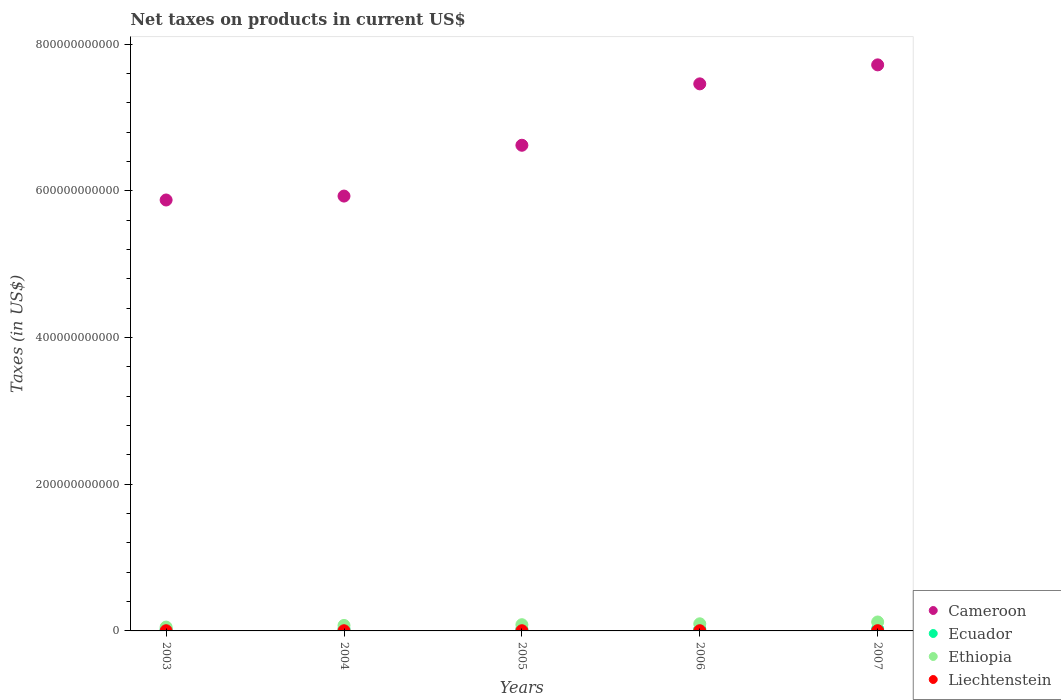What is the net taxes on products in Cameroon in 2003?
Give a very brief answer. 5.87e+11. Across all years, what is the maximum net taxes on products in Liechtenstein?
Provide a succinct answer. 3.35e+08. Across all years, what is the minimum net taxes on products in Cameroon?
Keep it short and to the point. 5.87e+11. In which year was the net taxes on products in Ecuador maximum?
Your answer should be very brief. 2007. In which year was the net taxes on products in Cameroon minimum?
Your answer should be compact. 2003. What is the total net taxes on products in Liechtenstein in the graph?
Offer a terse response. 1.40e+09. What is the difference between the net taxes on products in Ecuador in 2005 and that in 2007?
Provide a short and direct response. -1.95e+08. What is the difference between the net taxes on products in Liechtenstein in 2006 and the net taxes on products in Cameroon in 2005?
Offer a terse response. -6.62e+11. What is the average net taxes on products in Ecuador per year?
Provide a short and direct response. 2.35e+09. In the year 2004, what is the difference between the net taxes on products in Ethiopia and net taxes on products in Cameroon?
Make the answer very short. -5.85e+11. What is the ratio of the net taxes on products in Ecuador in 2004 to that in 2007?
Offer a very short reply. 0.96. Is the difference between the net taxes on products in Ethiopia in 2004 and 2007 greater than the difference between the net taxes on products in Cameroon in 2004 and 2007?
Make the answer very short. Yes. What is the difference between the highest and the second highest net taxes on products in Cameroon?
Provide a succinct answer. 2.59e+1. What is the difference between the highest and the lowest net taxes on products in Ethiopia?
Your response must be concise. 6.96e+09. In how many years, is the net taxes on products in Ecuador greater than the average net taxes on products in Ecuador taken over all years?
Keep it short and to the point. 2. Is the sum of the net taxes on products in Cameroon in 2004 and 2007 greater than the maximum net taxes on products in Liechtenstein across all years?
Offer a terse response. Yes. Is it the case that in every year, the sum of the net taxes on products in Ethiopia and net taxes on products in Ecuador  is greater than the net taxes on products in Liechtenstein?
Offer a very short reply. Yes. Does the net taxes on products in Ecuador monotonically increase over the years?
Your response must be concise. No. Is the net taxes on products in Cameroon strictly greater than the net taxes on products in Liechtenstein over the years?
Offer a terse response. Yes. How many dotlines are there?
Give a very brief answer. 4. How many years are there in the graph?
Provide a succinct answer. 5. What is the difference between two consecutive major ticks on the Y-axis?
Your answer should be compact. 2.00e+11. Does the graph contain grids?
Offer a very short reply. No. Where does the legend appear in the graph?
Your answer should be compact. Bottom right. How many legend labels are there?
Give a very brief answer. 4. How are the legend labels stacked?
Offer a terse response. Vertical. What is the title of the graph?
Provide a short and direct response. Net taxes on products in current US$. Does "Virgin Islands" appear as one of the legend labels in the graph?
Offer a terse response. No. What is the label or title of the X-axis?
Your answer should be very brief. Years. What is the label or title of the Y-axis?
Your answer should be compact. Taxes (in US$). What is the Taxes (in US$) in Cameroon in 2003?
Your response must be concise. 5.87e+11. What is the Taxes (in US$) in Ecuador in 2003?
Provide a short and direct response. 2.26e+09. What is the Taxes (in US$) of Ethiopia in 2003?
Give a very brief answer. 5.23e+09. What is the Taxes (in US$) in Liechtenstein in 2003?
Make the answer very short. 2.70e+08. What is the Taxes (in US$) of Cameroon in 2004?
Provide a short and direct response. 5.93e+11. What is the Taxes (in US$) of Ecuador in 2004?
Provide a succinct answer. 2.39e+09. What is the Taxes (in US$) of Ethiopia in 2004?
Ensure brevity in your answer.  7.48e+09. What is the Taxes (in US$) in Liechtenstein in 2004?
Give a very brief answer. 2.39e+08. What is the Taxes (in US$) in Cameroon in 2005?
Make the answer very short. 6.62e+11. What is the Taxes (in US$) of Ecuador in 2005?
Give a very brief answer. 2.30e+09. What is the Taxes (in US$) in Ethiopia in 2005?
Your answer should be very brief. 8.47e+09. What is the Taxes (in US$) in Liechtenstein in 2005?
Give a very brief answer. 2.62e+08. What is the Taxes (in US$) of Cameroon in 2006?
Provide a short and direct response. 7.46e+11. What is the Taxes (in US$) in Ecuador in 2006?
Give a very brief answer. 2.30e+09. What is the Taxes (in US$) of Ethiopia in 2006?
Your response must be concise. 9.70e+09. What is the Taxes (in US$) of Liechtenstein in 2006?
Provide a succinct answer. 2.92e+08. What is the Taxes (in US$) in Cameroon in 2007?
Offer a terse response. 7.72e+11. What is the Taxes (in US$) in Ecuador in 2007?
Your answer should be very brief. 2.50e+09. What is the Taxes (in US$) of Ethiopia in 2007?
Your answer should be compact. 1.22e+1. What is the Taxes (in US$) in Liechtenstein in 2007?
Your response must be concise. 3.35e+08. Across all years, what is the maximum Taxes (in US$) in Cameroon?
Keep it short and to the point. 7.72e+11. Across all years, what is the maximum Taxes (in US$) of Ecuador?
Your answer should be compact. 2.50e+09. Across all years, what is the maximum Taxes (in US$) in Ethiopia?
Offer a terse response. 1.22e+1. Across all years, what is the maximum Taxes (in US$) in Liechtenstein?
Offer a very short reply. 3.35e+08. Across all years, what is the minimum Taxes (in US$) of Cameroon?
Provide a succinct answer. 5.87e+11. Across all years, what is the minimum Taxes (in US$) in Ecuador?
Your response must be concise. 2.26e+09. Across all years, what is the minimum Taxes (in US$) of Ethiopia?
Your answer should be very brief. 5.23e+09. Across all years, what is the minimum Taxes (in US$) of Liechtenstein?
Your answer should be very brief. 2.39e+08. What is the total Taxes (in US$) in Cameroon in the graph?
Offer a very short reply. 3.36e+12. What is the total Taxes (in US$) of Ecuador in the graph?
Your answer should be very brief. 1.18e+1. What is the total Taxes (in US$) of Ethiopia in the graph?
Your response must be concise. 4.31e+1. What is the total Taxes (in US$) of Liechtenstein in the graph?
Make the answer very short. 1.40e+09. What is the difference between the Taxes (in US$) in Cameroon in 2003 and that in 2004?
Keep it short and to the point. -5.34e+09. What is the difference between the Taxes (in US$) in Ecuador in 2003 and that in 2004?
Ensure brevity in your answer.  -1.32e+08. What is the difference between the Taxes (in US$) in Ethiopia in 2003 and that in 2004?
Offer a terse response. -2.25e+09. What is the difference between the Taxes (in US$) in Liechtenstein in 2003 and that in 2004?
Ensure brevity in your answer.  3.08e+07. What is the difference between the Taxes (in US$) of Cameroon in 2003 and that in 2005?
Ensure brevity in your answer.  -7.46e+1. What is the difference between the Taxes (in US$) of Ecuador in 2003 and that in 2005?
Offer a terse response. -4.03e+07. What is the difference between the Taxes (in US$) in Ethiopia in 2003 and that in 2005?
Make the answer very short. -3.24e+09. What is the difference between the Taxes (in US$) in Liechtenstein in 2003 and that in 2005?
Keep it short and to the point. 8.20e+06. What is the difference between the Taxes (in US$) of Cameroon in 2003 and that in 2006?
Keep it short and to the point. -1.58e+11. What is the difference between the Taxes (in US$) in Ecuador in 2003 and that in 2006?
Keep it short and to the point. -4.33e+07. What is the difference between the Taxes (in US$) in Ethiopia in 2003 and that in 2006?
Provide a short and direct response. -4.47e+09. What is the difference between the Taxes (in US$) of Liechtenstein in 2003 and that in 2006?
Your answer should be very brief. -2.19e+07. What is the difference between the Taxes (in US$) of Cameroon in 2003 and that in 2007?
Give a very brief answer. -1.84e+11. What is the difference between the Taxes (in US$) of Ecuador in 2003 and that in 2007?
Make the answer very short. -2.35e+08. What is the difference between the Taxes (in US$) in Ethiopia in 2003 and that in 2007?
Offer a very short reply. -6.96e+09. What is the difference between the Taxes (in US$) in Liechtenstein in 2003 and that in 2007?
Give a very brief answer. -6.54e+07. What is the difference between the Taxes (in US$) in Cameroon in 2004 and that in 2005?
Provide a succinct answer. -6.93e+1. What is the difference between the Taxes (in US$) in Ecuador in 2004 and that in 2005?
Keep it short and to the point. 9.16e+07. What is the difference between the Taxes (in US$) of Ethiopia in 2004 and that in 2005?
Provide a short and direct response. -9.91e+08. What is the difference between the Taxes (in US$) of Liechtenstein in 2004 and that in 2005?
Provide a short and direct response. -2.26e+07. What is the difference between the Taxes (in US$) of Cameroon in 2004 and that in 2006?
Your answer should be very brief. -1.53e+11. What is the difference between the Taxes (in US$) in Ecuador in 2004 and that in 2006?
Provide a succinct answer. 8.86e+07. What is the difference between the Taxes (in US$) of Ethiopia in 2004 and that in 2006?
Your answer should be very brief. -2.22e+09. What is the difference between the Taxes (in US$) in Liechtenstein in 2004 and that in 2006?
Your response must be concise. -5.27e+07. What is the difference between the Taxes (in US$) in Cameroon in 2004 and that in 2007?
Your answer should be very brief. -1.79e+11. What is the difference between the Taxes (in US$) in Ecuador in 2004 and that in 2007?
Offer a very short reply. -1.03e+08. What is the difference between the Taxes (in US$) in Ethiopia in 2004 and that in 2007?
Make the answer very short. -4.71e+09. What is the difference between the Taxes (in US$) of Liechtenstein in 2004 and that in 2007?
Offer a terse response. -9.62e+07. What is the difference between the Taxes (in US$) in Cameroon in 2005 and that in 2006?
Offer a very short reply. -8.37e+1. What is the difference between the Taxes (in US$) of Ecuador in 2005 and that in 2006?
Your answer should be very brief. -2.96e+06. What is the difference between the Taxes (in US$) in Ethiopia in 2005 and that in 2006?
Your answer should be compact. -1.23e+09. What is the difference between the Taxes (in US$) in Liechtenstein in 2005 and that in 2006?
Give a very brief answer. -3.01e+07. What is the difference between the Taxes (in US$) of Cameroon in 2005 and that in 2007?
Give a very brief answer. -1.10e+11. What is the difference between the Taxes (in US$) of Ecuador in 2005 and that in 2007?
Provide a short and direct response. -1.95e+08. What is the difference between the Taxes (in US$) of Ethiopia in 2005 and that in 2007?
Your response must be concise. -3.72e+09. What is the difference between the Taxes (in US$) of Liechtenstein in 2005 and that in 2007?
Offer a terse response. -7.36e+07. What is the difference between the Taxes (in US$) in Cameroon in 2006 and that in 2007?
Your answer should be compact. -2.59e+1. What is the difference between the Taxes (in US$) of Ecuador in 2006 and that in 2007?
Keep it short and to the point. -1.92e+08. What is the difference between the Taxes (in US$) in Ethiopia in 2006 and that in 2007?
Provide a short and direct response. -2.49e+09. What is the difference between the Taxes (in US$) of Liechtenstein in 2006 and that in 2007?
Provide a succinct answer. -4.35e+07. What is the difference between the Taxes (in US$) of Cameroon in 2003 and the Taxes (in US$) of Ecuador in 2004?
Ensure brevity in your answer.  5.85e+11. What is the difference between the Taxes (in US$) of Cameroon in 2003 and the Taxes (in US$) of Ethiopia in 2004?
Keep it short and to the point. 5.80e+11. What is the difference between the Taxes (in US$) in Cameroon in 2003 and the Taxes (in US$) in Liechtenstein in 2004?
Your answer should be very brief. 5.87e+11. What is the difference between the Taxes (in US$) of Ecuador in 2003 and the Taxes (in US$) of Ethiopia in 2004?
Your response must be concise. -5.21e+09. What is the difference between the Taxes (in US$) of Ecuador in 2003 and the Taxes (in US$) of Liechtenstein in 2004?
Make the answer very short. 2.02e+09. What is the difference between the Taxes (in US$) of Ethiopia in 2003 and the Taxes (in US$) of Liechtenstein in 2004?
Make the answer very short. 4.99e+09. What is the difference between the Taxes (in US$) in Cameroon in 2003 and the Taxes (in US$) in Ecuador in 2005?
Keep it short and to the point. 5.85e+11. What is the difference between the Taxes (in US$) in Cameroon in 2003 and the Taxes (in US$) in Ethiopia in 2005?
Your response must be concise. 5.79e+11. What is the difference between the Taxes (in US$) in Cameroon in 2003 and the Taxes (in US$) in Liechtenstein in 2005?
Offer a terse response. 5.87e+11. What is the difference between the Taxes (in US$) of Ecuador in 2003 and the Taxes (in US$) of Ethiopia in 2005?
Provide a succinct answer. -6.21e+09. What is the difference between the Taxes (in US$) in Ecuador in 2003 and the Taxes (in US$) in Liechtenstein in 2005?
Give a very brief answer. 2.00e+09. What is the difference between the Taxes (in US$) in Ethiopia in 2003 and the Taxes (in US$) in Liechtenstein in 2005?
Your answer should be very brief. 4.97e+09. What is the difference between the Taxes (in US$) of Cameroon in 2003 and the Taxes (in US$) of Ecuador in 2006?
Give a very brief answer. 5.85e+11. What is the difference between the Taxes (in US$) in Cameroon in 2003 and the Taxes (in US$) in Ethiopia in 2006?
Keep it short and to the point. 5.78e+11. What is the difference between the Taxes (in US$) in Cameroon in 2003 and the Taxes (in US$) in Liechtenstein in 2006?
Provide a short and direct response. 5.87e+11. What is the difference between the Taxes (in US$) of Ecuador in 2003 and the Taxes (in US$) of Ethiopia in 2006?
Provide a succinct answer. -7.44e+09. What is the difference between the Taxes (in US$) in Ecuador in 2003 and the Taxes (in US$) in Liechtenstein in 2006?
Keep it short and to the point. 1.97e+09. What is the difference between the Taxes (in US$) in Ethiopia in 2003 and the Taxes (in US$) in Liechtenstein in 2006?
Your response must be concise. 4.94e+09. What is the difference between the Taxes (in US$) of Cameroon in 2003 and the Taxes (in US$) of Ecuador in 2007?
Your answer should be compact. 5.85e+11. What is the difference between the Taxes (in US$) in Cameroon in 2003 and the Taxes (in US$) in Ethiopia in 2007?
Keep it short and to the point. 5.75e+11. What is the difference between the Taxes (in US$) of Cameroon in 2003 and the Taxes (in US$) of Liechtenstein in 2007?
Offer a terse response. 5.87e+11. What is the difference between the Taxes (in US$) of Ecuador in 2003 and the Taxes (in US$) of Ethiopia in 2007?
Make the answer very short. -9.92e+09. What is the difference between the Taxes (in US$) in Ecuador in 2003 and the Taxes (in US$) in Liechtenstein in 2007?
Make the answer very short. 1.93e+09. What is the difference between the Taxes (in US$) in Ethiopia in 2003 and the Taxes (in US$) in Liechtenstein in 2007?
Provide a succinct answer. 4.89e+09. What is the difference between the Taxes (in US$) in Cameroon in 2004 and the Taxes (in US$) in Ecuador in 2005?
Your response must be concise. 5.90e+11. What is the difference between the Taxes (in US$) of Cameroon in 2004 and the Taxes (in US$) of Ethiopia in 2005?
Offer a very short reply. 5.84e+11. What is the difference between the Taxes (in US$) in Cameroon in 2004 and the Taxes (in US$) in Liechtenstein in 2005?
Offer a terse response. 5.93e+11. What is the difference between the Taxes (in US$) of Ecuador in 2004 and the Taxes (in US$) of Ethiopia in 2005?
Your answer should be very brief. -6.07e+09. What is the difference between the Taxes (in US$) of Ecuador in 2004 and the Taxes (in US$) of Liechtenstein in 2005?
Provide a succinct answer. 2.13e+09. What is the difference between the Taxes (in US$) in Ethiopia in 2004 and the Taxes (in US$) in Liechtenstein in 2005?
Your answer should be compact. 7.21e+09. What is the difference between the Taxes (in US$) of Cameroon in 2004 and the Taxes (in US$) of Ecuador in 2006?
Your answer should be very brief. 5.90e+11. What is the difference between the Taxes (in US$) of Cameroon in 2004 and the Taxes (in US$) of Ethiopia in 2006?
Provide a short and direct response. 5.83e+11. What is the difference between the Taxes (in US$) in Cameroon in 2004 and the Taxes (in US$) in Liechtenstein in 2006?
Offer a terse response. 5.92e+11. What is the difference between the Taxes (in US$) in Ecuador in 2004 and the Taxes (in US$) in Ethiopia in 2006?
Offer a very short reply. -7.30e+09. What is the difference between the Taxes (in US$) in Ecuador in 2004 and the Taxes (in US$) in Liechtenstein in 2006?
Your answer should be compact. 2.10e+09. What is the difference between the Taxes (in US$) in Ethiopia in 2004 and the Taxes (in US$) in Liechtenstein in 2006?
Your answer should be very brief. 7.18e+09. What is the difference between the Taxes (in US$) in Cameroon in 2004 and the Taxes (in US$) in Ecuador in 2007?
Offer a very short reply. 5.90e+11. What is the difference between the Taxes (in US$) of Cameroon in 2004 and the Taxes (in US$) of Ethiopia in 2007?
Give a very brief answer. 5.81e+11. What is the difference between the Taxes (in US$) in Cameroon in 2004 and the Taxes (in US$) in Liechtenstein in 2007?
Your answer should be very brief. 5.92e+11. What is the difference between the Taxes (in US$) of Ecuador in 2004 and the Taxes (in US$) of Ethiopia in 2007?
Ensure brevity in your answer.  -9.79e+09. What is the difference between the Taxes (in US$) of Ecuador in 2004 and the Taxes (in US$) of Liechtenstein in 2007?
Your answer should be very brief. 2.06e+09. What is the difference between the Taxes (in US$) of Ethiopia in 2004 and the Taxes (in US$) of Liechtenstein in 2007?
Provide a succinct answer. 7.14e+09. What is the difference between the Taxes (in US$) in Cameroon in 2005 and the Taxes (in US$) in Ecuador in 2006?
Make the answer very short. 6.60e+11. What is the difference between the Taxes (in US$) in Cameroon in 2005 and the Taxes (in US$) in Ethiopia in 2006?
Your answer should be compact. 6.52e+11. What is the difference between the Taxes (in US$) in Cameroon in 2005 and the Taxes (in US$) in Liechtenstein in 2006?
Your answer should be very brief. 6.62e+11. What is the difference between the Taxes (in US$) of Ecuador in 2005 and the Taxes (in US$) of Ethiopia in 2006?
Offer a very short reply. -7.40e+09. What is the difference between the Taxes (in US$) of Ecuador in 2005 and the Taxes (in US$) of Liechtenstein in 2006?
Your response must be concise. 2.01e+09. What is the difference between the Taxes (in US$) in Ethiopia in 2005 and the Taxes (in US$) in Liechtenstein in 2006?
Give a very brief answer. 8.18e+09. What is the difference between the Taxes (in US$) in Cameroon in 2005 and the Taxes (in US$) in Ecuador in 2007?
Offer a terse response. 6.60e+11. What is the difference between the Taxes (in US$) in Cameroon in 2005 and the Taxes (in US$) in Ethiopia in 2007?
Your response must be concise. 6.50e+11. What is the difference between the Taxes (in US$) in Cameroon in 2005 and the Taxes (in US$) in Liechtenstein in 2007?
Your answer should be compact. 6.62e+11. What is the difference between the Taxes (in US$) in Ecuador in 2005 and the Taxes (in US$) in Ethiopia in 2007?
Offer a very short reply. -9.88e+09. What is the difference between the Taxes (in US$) in Ecuador in 2005 and the Taxes (in US$) in Liechtenstein in 2007?
Your answer should be compact. 1.97e+09. What is the difference between the Taxes (in US$) of Ethiopia in 2005 and the Taxes (in US$) of Liechtenstein in 2007?
Your answer should be compact. 8.13e+09. What is the difference between the Taxes (in US$) in Cameroon in 2006 and the Taxes (in US$) in Ecuador in 2007?
Keep it short and to the point. 7.43e+11. What is the difference between the Taxes (in US$) in Cameroon in 2006 and the Taxes (in US$) in Ethiopia in 2007?
Give a very brief answer. 7.34e+11. What is the difference between the Taxes (in US$) of Cameroon in 2006 and the Taxes (in US$) of Liechtenstein in 2007?
Provide a succinct answer. 7.45e+11. What is the difference between the Taxes (in US$) of Ecuador in 2006 and the Taxes (in US$) of Ethiopia in 2007?
Keep it short and to the point. -9.88e+09. What is the difference between the Taxes (in US$) of Ecuador in 2006 and the Taxes (in US$) of Liechtenstein in 2007?
Offer a terse response. 1.97e+09. What is the difference between the Taxes (in US$) in Ethiopia in 2006 and the Taxes (in US$) in Liechtenstein in 2007?
Offer a very short reply. 9.36e+09. What is the average Taxes (in US$) in Cameroon per year?
Give a very brief answer. 6.72e+11. What is the average Taxes (in US$) in Ecuador per year?
Your answer should be compact. 2.35e+09. What is the average Taxes (in US$) of Ethiopia per year?
Your response must be concise. 8.61e+09. What is the average Taxes (in US$) of Liechtenstein per year?
Keep it short and to the point. 2.80e+08. In the year 2003, what is the difference between the Taxes (in US$) in Cameroon and Taxes (in US$) in Ecuador?
Your answer should be compact. 5.85e+11. In the year 2003, what is the difference between the Taxes (in US$) in Cameroon and Taxes (in US$) in Ethiopia?
Offer a terse response. 5.82e+11. In the year 2003, what is the difference between the Taxes (in US$) of Cameroon and Taxes (in US$) of Liechtenstein?
Ensure brevity in your answer.  5.87e+11. In the year 2003, what is the difference between the Taxes (in US$) of Ecuador and Taxes (in US$) of Ethiopia?
Offer a very short reply. -2.97e+09. In the year 2003, what is the difference between the Taxes (in US$) of Ecuador and Taxes (in US$) of Liechtenstein?
Your response must be concise. 1.99e+09. In the year 2003, what is the difference between the Taxes (in US$) of Ethiopia and Taxes (in US$) of Liechtenstein?
Your response must be concise. 4.96e+09. In the year 2004, what is the difference between the Taxes (in US$) in Cameroon and Taxes (in US$) in Ecuador?
Make the answer very short. 5.90e+11. In the year 2004, what is the difference between the Taxes (in US$) of Cameroon and Taxes (in US$) of Ethiopia?
Make the answer very short. 5.85e+11. In the year 2004, what is the difference between the Taxes (in US$) of Cameroon and Taxes (in US$) of Liechtenstein?
Provide a short and direct response. 5.93e+11. In the year 2004, what is the difference between the Taxes (in US$) in Ecuador and Taxes (in US$) in Ethiopia?
Keep it short and to the point. -5.08e+09. In the year 2004, what is the difference between the Taxes (in US$) in Ecuador and Taxes (in US$) in Liechtenstein?
Your answer should be very brief. 2.15e+09. In the year 2004, what is the difference between the Taxes (in US$) in Ethiopia and Taxes (in US$) in Liechtenstein?
Your response must be concise. 7.24e+09. In the year 2005, what is the difference between the Taxes (in US$) in Cameroon and Taxes (in US$) in Ecuador?
Your answer should be compact. 6.60e+11. In the year 2005, what is the difference between the Taxes (in US$) in Cameroon and Taxes (in US$) in Ethiopia?
Offer a very short reply. 6.54e+11. In the year 2005, what is the difference between the Taxes (in US$) in Cameroon and Taxes (in US$) in Liechtenstein?
Give a very brief answer. 6.62e+11. In the year 2005, what is the difference between the Taxes (in US$) in Ecuador and Taxes (in US$) in Ethiopia?
Provide a succinct answer. -6.17e+09. In the year 2005, what is the difference between the Taxes (in US$) in Ecuador and Taxes (in US$) in Liechtenstein?
Provide a succinct answer. 2.04e+09. In the year 2005, what is the difference between the Taxes (in US$) of Ethiopia and Taxes (in US$) of Liechtenstein?
Provide a succinct answer. 8.21e+09. In the year 2006, what is the difference between the Taxes (in US$) of Cameroon and Taxes (in US$) of Ecuador?
Offer a very short reply. 7.43e+11. In the year 2006, what is the difference between the Taxes (in US$) in Cameroon and Taxes (in US$) in Ethiopia?
Provide a succinct answer. 7.36e+11. In the year 2006, what is the difference between the Taxes (in US$) in Cameroon and Taxes (in US$) in Liechtenstein?
Give a very brief answer. 7.45e+11. In the year 2006, what is the difference between the Taxes (in US$) of Ecuador and Taxes (in US$) of Ethiopia?
Provide a succinct answer. -7.39e+09. In the year 2006, what is the difference between the Taxes (in US$) of Ecuador and Taxes (in US$) of Liechtenstein?
Your answer should be compact. 2.01e+09. In the year 2006, what is the difference between the Taxes (in US$) of Ethiopia and Taxes (in US$) of Liechtenstein?
Make the answer very short. 9.41e+09. In the year 2007, what is the difference between the Taxes (in US$) of Cameroon and Taxes (in US$) of Ecuador?
Keep it short and to the point. 7.69e+11. In the year 2007, what is the difference between the Taxes (in US$) in Cameroon and Taxes (in US$) in Ethiopia?
Your response must be concise. 7.59e+11. In the year 2007, what is the difference between the Taxes (in US$) in Cameroon and Taxes (in US$) in Liechtenstein?
Offer a very short reply. 7.71e+11. In the year 2007, what is the difference between the Taxes (in US$) in Ecuador and Taxes (in US$) in Ethiopia?
Offer a very short reply. -9.69e+09. In the year 2007, what is the difference between the Taxes (in US$) in Ecuador and Taxes (in US$) in Liechtenstein?
Your answer should be compact. 2.16e+09. In the year 2007, what is the difference between the Taxes (in US$) in Ethiopia and Taxes (in US$) in Liechtenstein?
Keep it short and to the point. 1.19e+1. What is the ratio of the Taxes (in US$) in Ecuador in 2003 to that in 2004?
Make the answer very short. 0.94. What is the ratio of the Taxes (in US$) in Ethiopia in 2003 to that in 2004?
Your answer should be very brief. 0.7. What is the ratio of the Taxes (in US$) of Liechtenstein in 2003 to that in 2004?
Ensure brevity in your answer.  1.13. What is the ratio of the Taxes (in US$) in Cameroon in 2003 to that in 2005?
Your answer should be very brief. 0.89. What is the ratio of the Taxes (in US$) in Ecuador in 2003 to that in 2005?
Your answer should be compact. 0.98. What is the ratio of the Taxes (in US$) of Ethiopia in 2003 to that in 2005?
Provide a succinct answer. 0.62. What is the ratio of the Taxes (in US$) of Liechtenstein in 2003 to that in 2005?
Ensure brevity in your answer.  1.03. What is the ratio of the Taxes (in US$) of Cameroon in 2003 to that in 2006?
Offer a very short reply. 0.79. What is the ratio of the Taxes (in US$) in Ecuador in 2003 to that in 2006?
Provide a short and direct response. 0.98. What is the ratio of the Taxes (in US$) in Ethiopia in 2003 to that in 2006?
Keep it short and to the point. 0.54. What is the ratio of the Taxes (in US$) in Liechtenstein in 2003 to that in 2006?
Offer a terse response. 0.93. What is the ratio of the Taxes (in US$) in Cameroon in 2003 to that in 2007?
Ensure brevity in your answer.  0.76. What is the ratio of the Taxes (in US$) in Ecuador in 2003 to that in 2007?
Your answer should be very brief. 0.91. What is the ratio of the Taxes (in US$) in Ethiopia in 2003 to that in 2007?
Make the answer very short. 0.43. What is the ratio of the Taxes (in US$) of Liechtenstein in 2003 to that in 2007?
Offer a terse response. 0.81. What is the ratio of the Taxes (in US$) in Cameroon in 2004 to that in 2005?
Give a very brief answer. 0.9. What is the ratio of the Taxes (in US$) of Ecuador in 2004 to that in 2005?
Make the answer very short. 1.04. What is the ratio of the Taxes (in US$) of Ethiopia in 2004 to that in 2005?
Your answer should be compact. 0.88. What is the ratio of the Taxes (in US$) in Liechtenstein in 2004 to that in 2005?
Provide a short and direct response. 0.91. What is the ratio of the Taxes (in US$) in Cameroon in 2004 to that in 2006?
Provide a short and direct response. 0.79. What is the ratio of the Taxes (in US$) in Ecuador in 2004 to that in 2006?
Provide a short and direct response. 1.04. What is the ratio of the Taxes (in US$) of Ethiopia in 2004 to that in 2006?
Ensure brevity in your answer.  0.77. What is the ratio of the Taxes (in US$) of Liechtenstein in 2004 to that in 2006?
Your answer should be very brief. 0.82. What is the ratio of the Taxes (in US$) in Cameroon in 2004 to that in 2007?
Keep it short and to the point. 0.77. What is the ratio of the Taxes (in US$) of Ecuador in 2004 to that in 2007?
Provide a succinct answer. 0.96. What is the ratio of the Taxes (in US$) in Ethiopia in 2004 to that in 2007?
Keep it short and to the point. 0.61. What is the ratio of the Taxes (in US$) in Liechtenstein in 2004 to that in 2007?
Your answer should be very brief. 0.71. What is the ratio of the Taxes (in US$) in Cameroon in 2005 to that in 2006?
Make the answer very short. 0.89. What is the ratio of the Taxes (in US$) of Ecuador in 2005 to that in 2006?
Your answer should be compact. 1. What is the ratio of the Taxes (in US$) of Ethiopia in 2005 to that in 2006?
Your response must be concise. 0.87. What is the ratio of the Taxes (in US$) in Liechtenstein in 2005 to that in 2006?
Give a very brief answer. 0.9. What is the ratio of the Taxes (in US$) of Cameroon in 2005 to that in 2007?
Keep it short and to the point. 0.86. What is the ratio of the Taxes (in US$) in Ecuador in 2005 to that in 2007?
Give a very brief answer. 0.92. What is the ratio of the Taxes (in US$) of Ethiopia in 2005 to that in 2007?
Your response must be concise. 0.69. What is the ratio of the Taxes (in US$) of Liechtenstein in 2005 to that in 2007?
Give a very brief answer. 0.78. What is the ratio of the Taxes (in US$) of Cameroon in 2006 to that in 2007?
Provide a succinct answer. 0.97. What is the ratio of the Taxes (in US$) of Ethiopia in 2006 to that in 2007?
Your answer should be compact. 0.8. What is the ratio of the Taxes (in US$) of Liechtenstein in 2006 to that in 2007?
Offer a very short reply. 0.87. What is the difference between the highest and the second highest Taxes (in US$) in Cameroon?
Make the answer very short. 2.59e+1. What is the difference between the highest and the second highest Taxes (in US$) in Ecuador?
Provide a short and direct response. 1.03e+08. What is the difference between the highest and the second highest Taxes (in US$) in Ethiopia?
Provide a succinct answer. 2.49e+09. What is the difference between the highest and the second highest Taxes (in US$) in Liechtenstein?
Your response must be concise. 4.35e+07. What is the difference between the highest and the lowest Taxes (in US$) of Cameroon?
Your answer should be very brief. 1.84e+11. What is the difference between the highest and the lowest Taxes (in US$) in Ecuador?
Offer a very short reply. 2.35e+08. What is the difference between the highest and the lowest Taxes (in US$) of Ethiopia?
Your answer should be very brief. 6.96e+09. What is the difference between the highest and the lowest Taxes (in US$) in Liechtenstein?
Give a very brief answer. 9.62e+07. 